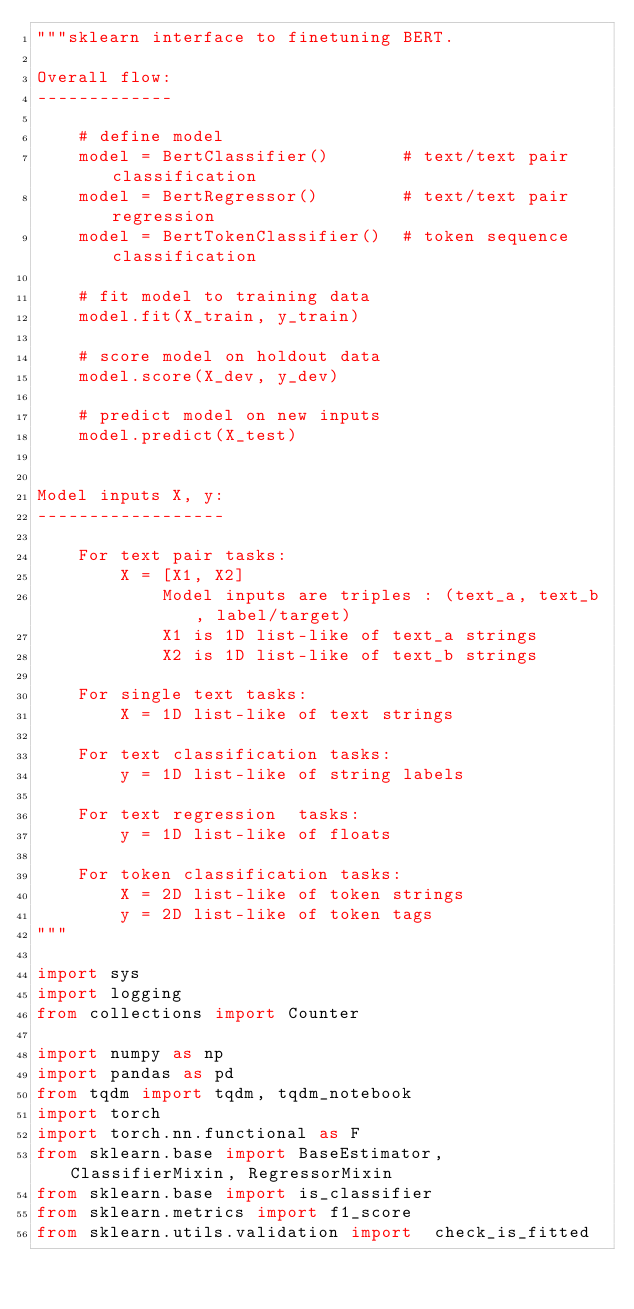<code> <loc_0><loc_0><loc_500><loc_500><_Python_>"""sklearn interface to finetuning BERT.

Overall flow:
-------------

    # define model
    model = BertClassifier()       # text/text pair classification
    model = BertRegressor()        # text/text pair regression
    model = BertTokenClassifier()  # token sequence classification

    # fit model to training data
    model.fit(X_train, y_train)

    # score model on holdout data
    model.score(X_dev, y_dev)

    # predict model on new inputs
    model.predict(X_test)


Model inputs X, y:
------------------

    For text pair tasks:
        X = [X1, X2]
            Model inputs are triples : (text_a, text_b, label/target)
            X1 is 1D list-like of text_a strings
            X2 is 1D list-like of text_b strings

    For single text tasks:
        X = 1D list-like of text strings

    For text classification tasks:
        y = 1D list-like of string labels

    For text regression  tasks:
        y = 1D list-like of floats

    For token classification tasks:
        X = 2D list-like of token strings
        y = 2D list-like of token tags
"""

import sys
import logging
from collections import Counter

import numpy as np
import pandas as pd
from tqdm import tqdm, tqdm_notebook
import torch
import torch.nn.functional as F
from sklearn.base import BaseEstimator, ClassifierMixin, RegressorMixin
from sklearn.base import is_classifier
from sklearn.metrics import f1_score
from sklearn.utils.validation import  check_is_fitted</code> 